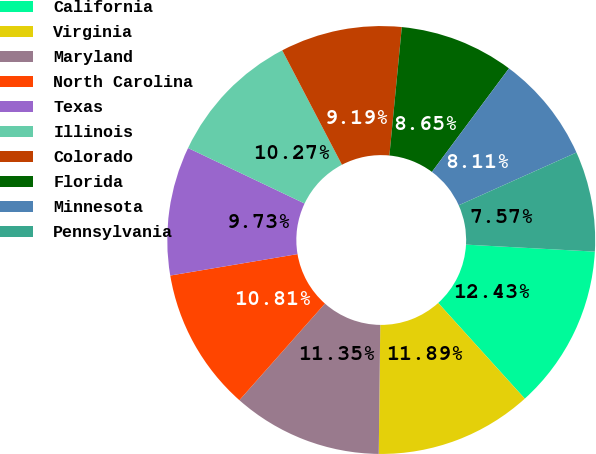Convert chart to OTSL. <chart><loc_0><loc_0><loc_500><loc_500><pie_chart><fcel>California<fcel>Virginia<fcel>Maryland<fcel>North Carolina<fcel>Texas<fcel>Illinois<fcel>Colorado<fcel>Florida<fcel>Minnesota<fcel>Pennsylvania<nl><fcel>12.43%<fcel>11.89%<fcel>11.35%<fcel>10.81%<fcel>9.73%<fcel>10.27%<fcel>9.19%<fcel>8.65%<fcel>8.11%<fcel>7.57%<nl></chart> 